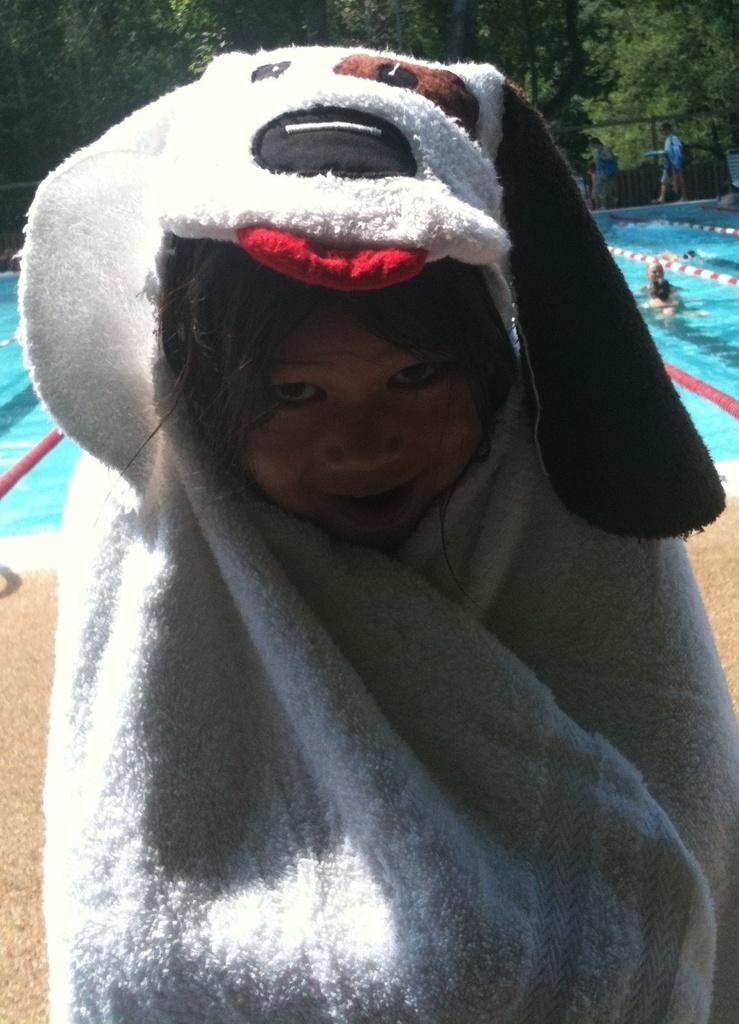What is the main subject of the image? There is a child in the image. What is the child doing in the image? The child is smiling in the image. What is the child holding in the image? The child is holding a towel in the image. What can be seen in the background of the image? There are people, water, trees, and objects visible in the background of the image. What type of grape is the child eating in the image? There is no grape present in the image, and the child is not eating anything. What type of pleasure is the child experiencing in the image? The image does not convey any specific emotions beyond the child's smile, so it is not possible to determine the type of pleasure the child is experiencing. 